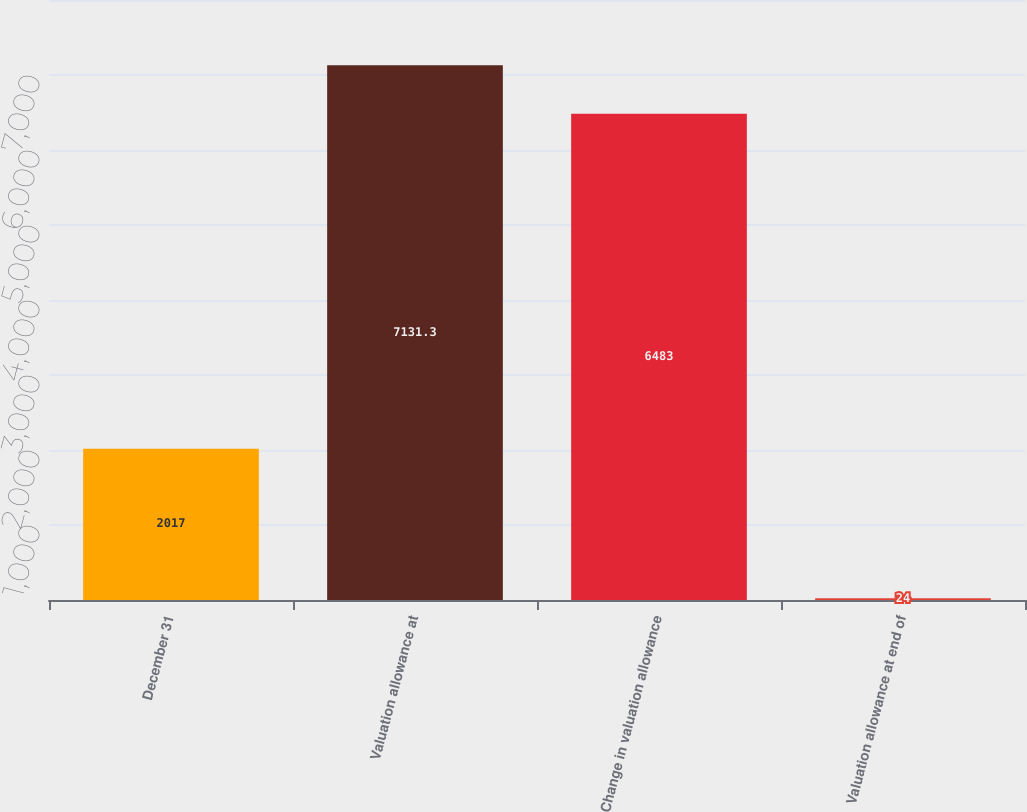Convert chart to OTSL. <chart><loc_0><loc_0><loc_500><loc_500><bar_chart><fcel>December 31<fcel>Valuation allowance at<fcel>Change in valuation allowance<fcel>Valuation allowance at end of<nl><fcel>2017<fcel>7131.3<fcel>6483<fcel>24<nl></chart> 